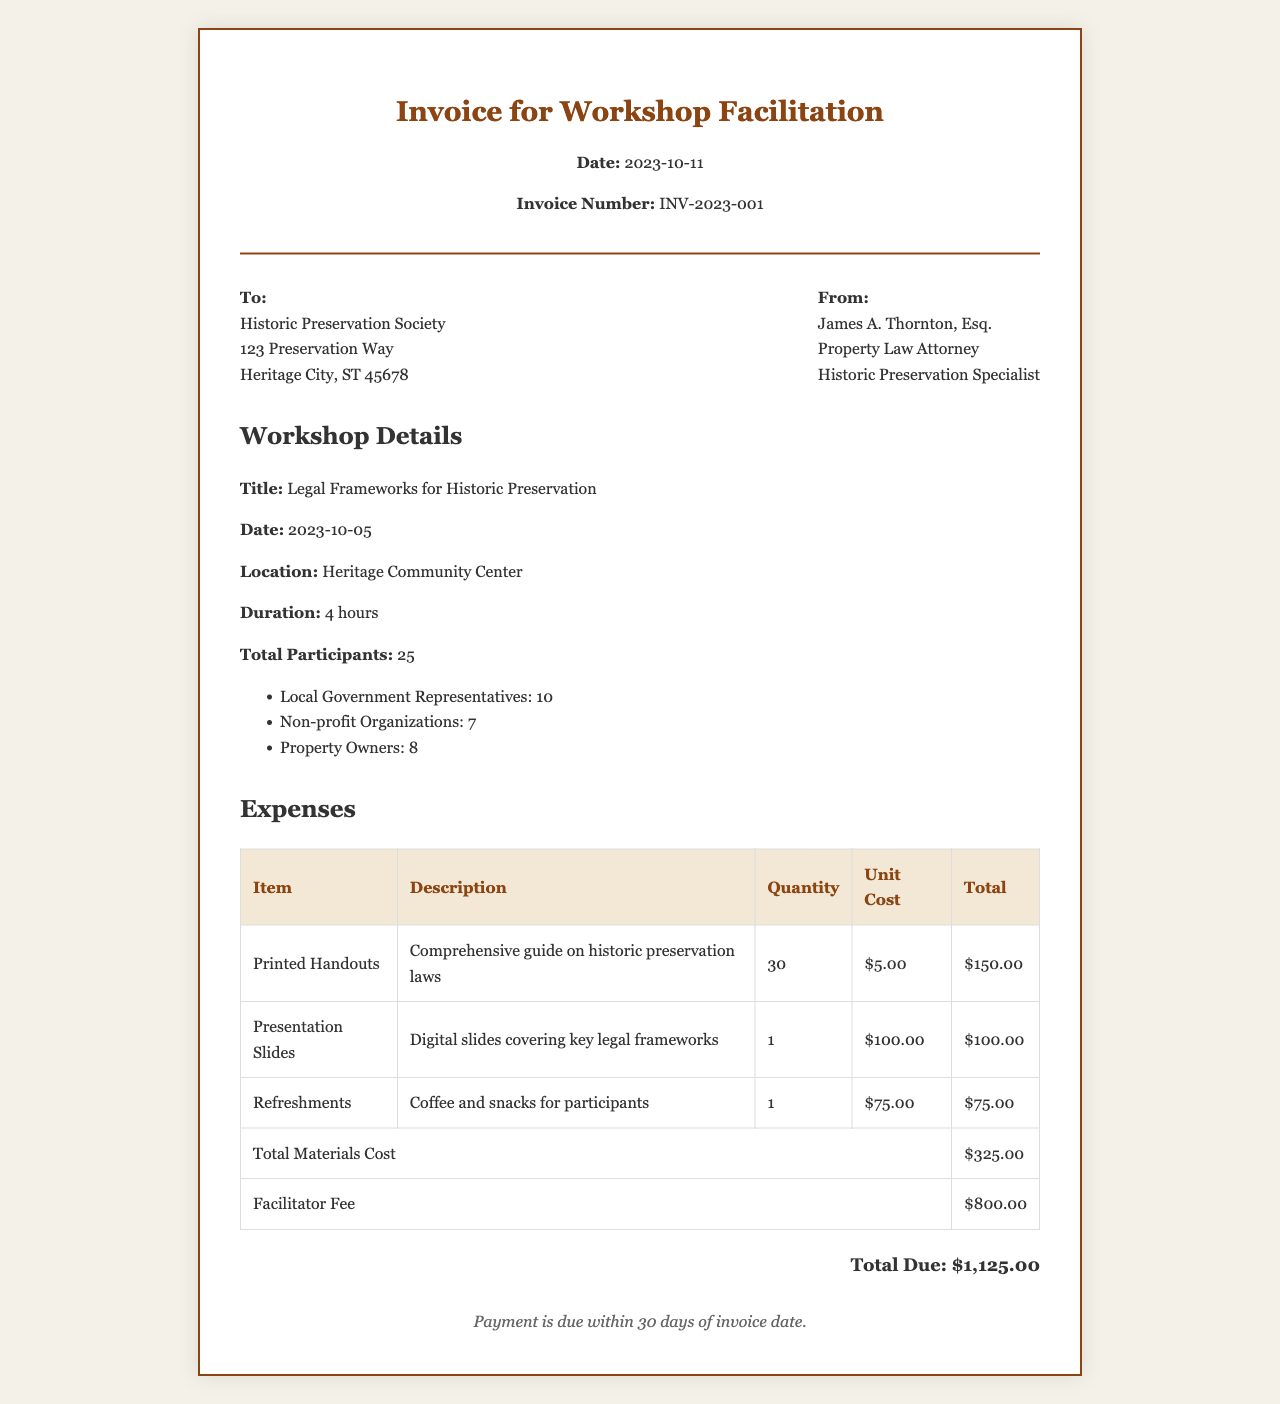what is the invoice number? The invoice number is listed under the header section of the document, which identifies the specific invoice.
Answer: INV-2023-001 who facilitated the workshop? The facilitator of the workshop is mentioned as James A. Thornton, Esq., who is a Property Law Attorney and Historic Preservation Specialist.
Answer: James A. Thornton, Esq what is the date of the workshop? The date of the workshop is provided in the workshop details section, specifying when the event took place.
Answer: 2023-10-05 how many total participants attended the workshop? The total number of participants is stated in the workshop details, indicating the sum of attendees from different groups.
Answer: 25 what is the total due amount on the invoice? The total due amount is provided at the end of the expenses section, summarizing all the costs incurred.
Answer: $1,125.00 how many printed handouts were provided? The quantity of printed handouts is listed in the expenses table, showing how many were made available for participants.
Answer: 30 what is the unit cost for presentation slides? The unit cost for presentation slides is indicated in the expenses table, showing the price for that specific item.
Answer: $100.00 what is the total cost for refreshments? The total cost for refreshments is listed in the expenses table, detailing the amount spent on coffee and snacks.
Answer: $75.00 what payment terms are specified on the invoice? The payment terms are mentioned at the bottom of the invoice, indicating how long after the invoice date payment is expected.
Answer: Payment is due within 30 days of invoice date 